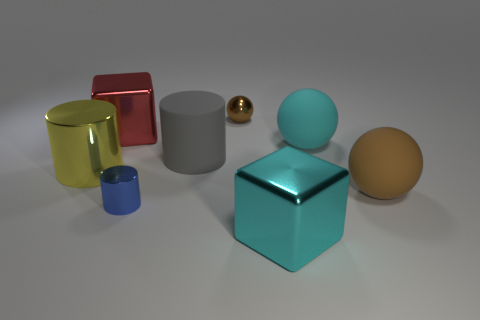What number of small things are cyan shiny things or yellow metal cylinders?
Ensure brevity in your answer.  0. What size is the other brown thing that is the same shape as the big brown matte thing?
Your response must be concise. Small. What is the large cylinder right of the cube that is to the left of the gray rubber cylinder made of?
Your response must be concise. Rubber. How many matte things are either tiny blue objects or large balls?
Keep it short and to the point. 2. There is another big rubber object that is the same shape as the big brown rubber object; what color is it?
Make the answer very short. Cyan. How many objects are the same color as the small metallic sphere?
Make the answer very short. 1. Are there any shiny cubes that are behind the matte thing that is on the left side of the cyan cube?
Keep it short and to the point. Yes. What number of blocks are on the left side of the brown metal object and in front of the brown rubber ball?
Ensure brevity in your answer.  0. How many small brown objects have the same material as the big red cube?
Make the answer very short. 1. There is a brown object behind the large cylinder on the right side of the red cube; what is its size?
Offer a terse response. Small. 